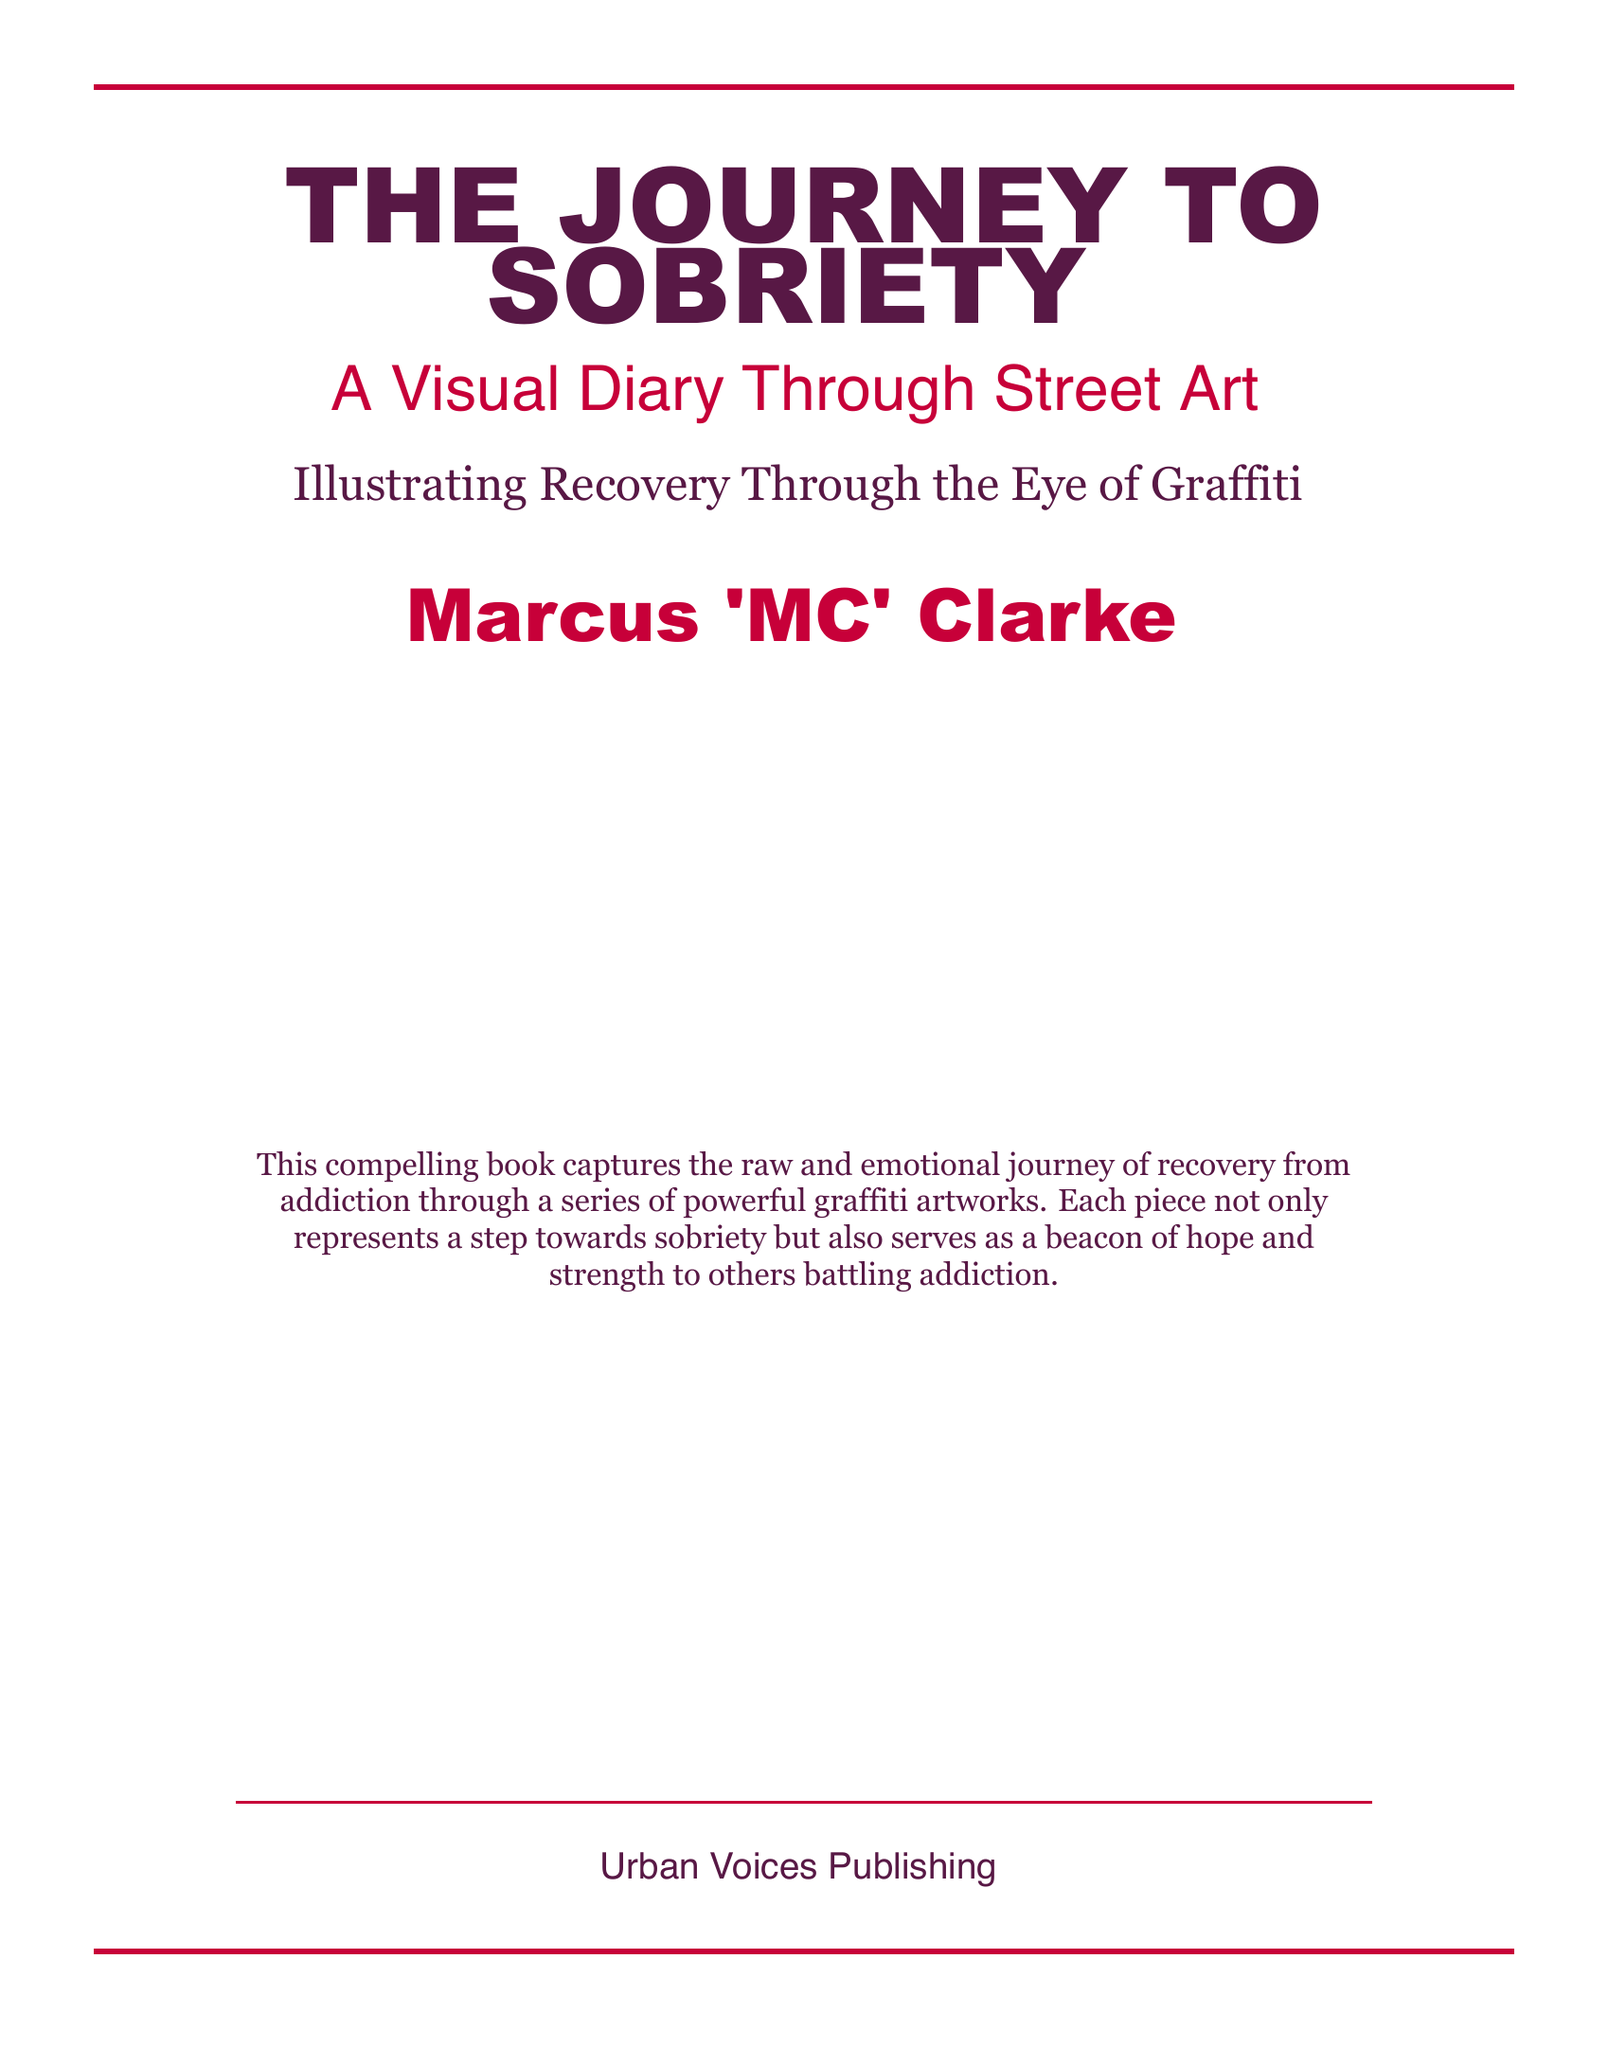What is the title of the book? The title is prominently displayed at the top of the document.
Answer: THE JOURNEY TO SOBRIETY Who is the author of the book? The author's name is listed below the title.
Answer: Marcus 'MC' Clarke What is the subtitle of the book? The subtitle provides additional context to the title and can be found under it.
Answer: A Visual Diary Through Street Art What type of publication is "Urban Voices Publishing"? The document specifies the publisher at the bottom.
Answer: Publisher What is the primary focus of the book? The description summarizes the main theme of the book.
Answer: Recovery from addiction How are the recovery steps illustrated in the book? The description indicates the method used to convey the theme.
Answer: Graffiti artworks What does each artwork symbolize? The description explains the significance of the art pieces in the context of the book.
Answer: A step towards sobriety What color is used for the title font? The title font color is specified in the document.
Answer: Dark purple How many points are in the horizontal rules at the top and bottom? The rules' thickness is indicated in the visual layout.
Answer: 2pt What type of visual art is highlighted in this book? The document mentions the specific art form within the content.
Answer: Graffiti 